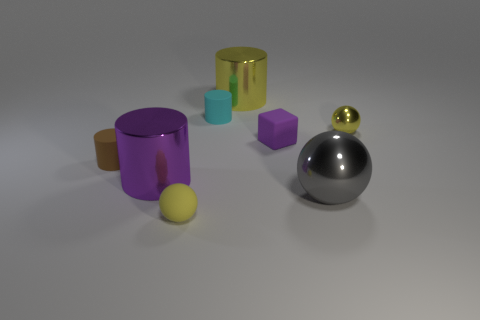Subtract all yellow cubes. How many yellow spheres are left? 2 Add 1 tiny yellow things. How many objects exist? 9 Subtract all yellow cylinders. How many cylinders are left? 3 Subtract all yellow shiny cylinders. How many cylinders are left? 3 Subtract all red cylinders. Subtract all red spheres. How many cylinders are left? 4 Add 5 big spheres. How many big spheres exist? 6 Subtract 0 green cylinders. How many objects are left? 8 Subtract all blocks. How many objects are left? 7 Subtract all yellow metallic cubes. Subtract all yellow metallic balls. How many objects are left? 7 Add 1 cyan rubber cylinders. How many cyan rubber cylinders are left? 2 